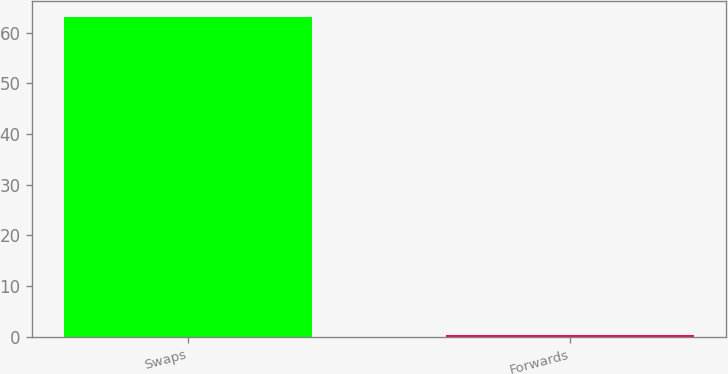Convert chart. <chart><loc_0><loc_0><loc_500><loc_500><bar_chart><fcel>Swaps<fcel>Forwards<nl><fcel>63.1<fcel>0.4<nl></chart> 